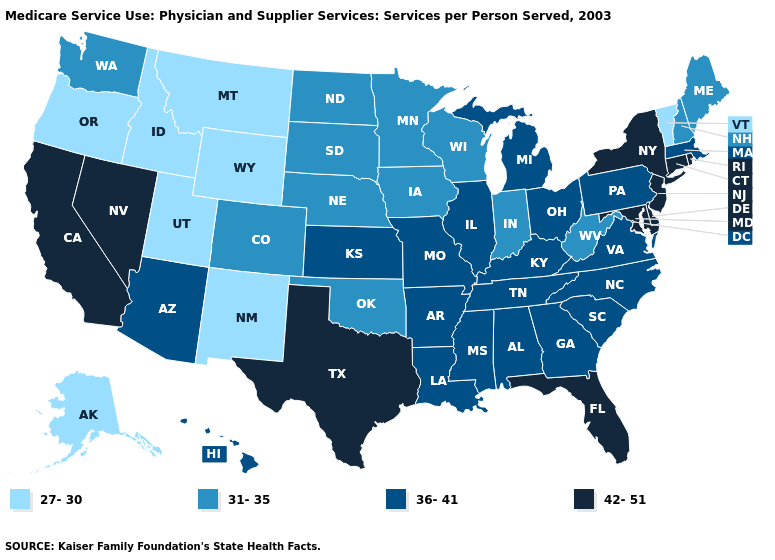Does Montana have a lower value than Vermont?
Quick response, please. No. Name the states that have a value in the range 42-51?
Quick response, please. California, Connecticut, Delaware, Florida, Maryland, Nevada, New Jersey, New York, Rhode Island, Texas. What is the value of Louisiana?
Keep it brief. 36-41. What is the value of Washington?
Short answer required. 31-35. What is the value of South Carolina?
Be succinct. 36-41. Does Utah have the same value as Hawaii?
Answer briefly. No. Does Utah have the lowest value in the USA?
Short answer required. Yes. What is the value of Rhode Island?
Quick response, please. 42-51. Which states have the lowest value in the MidWest?
Short answer required. Indiana, Iowa, Minnesota, Nebraska, North Dakota, South Dakota, Wisconsin. Does Illinois have a lower value than Kentucky?
Be succinct. No. What is the value of Iowa?
Keep it brief. 31-35. What is the lowest value in states that border Wisconsin?
Quick response, please. 31-35. Among the states that border New York , does Connecticut have the highest value?
Be succinct. Yes. Is the legend a continuous bar?
Be succinct. No. Does Washington have the highest value in the USA?
Quick response, please. No. 